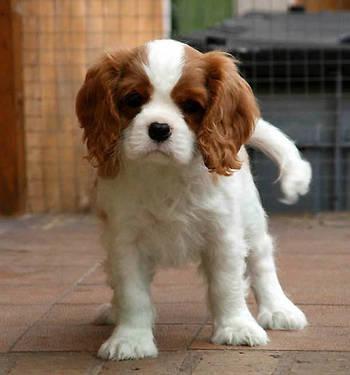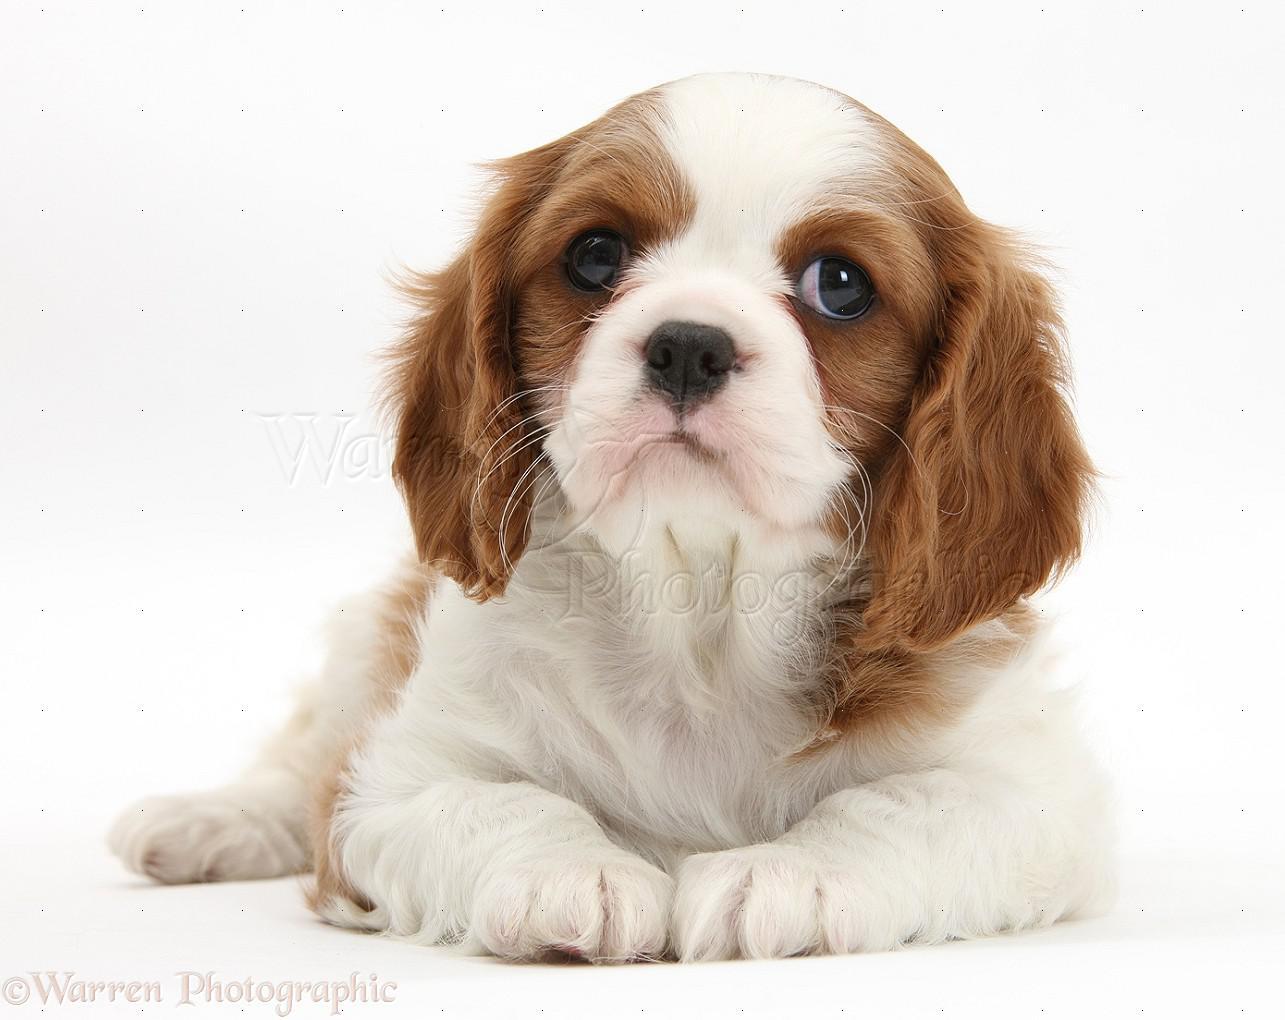The first image is the image on the left, the second image is the image on the right. Analyze the images presented: Is the assertion "In one image there is a lone Cavalier King Charles Spaniel laying down looking at the camera in the center of the image." valid? Answer yes or no. Yes. 